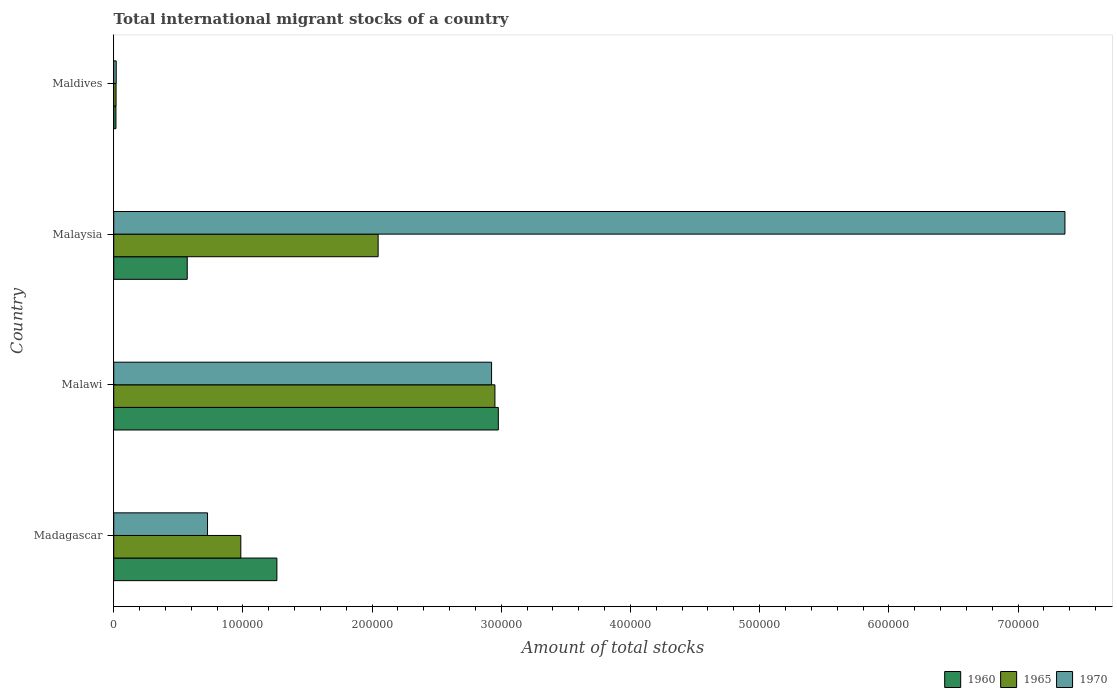How many different coloured bars are there?
Provide a succinct answer. 3. Are the number of bars on each tick of the Y-axis equal?
Keep it short and to the point. Yes. How many bars are there on the 4th tick from the top?
Your answer should be very brief. 3. What is the label of the 4th group of bars from the top?
Your response must be concise. Madagascar. In how many cases, is the number of bars for a given country not equal to the number of legend labels?
Keep it short and to the point. 0. What is the amount of total stocks in in 1960 in Malawi?
Make the answer very short. 2.98e+05. Across all countries, what is the maximum amount of total stocks in in 1960?
Your answer should be very brief. 2.98e+05. Across all countries, what is the minimum amount of total stocks in in 1970?
Provide a short and direct response. 1916. In which country was the amount of total stocks in in 1970 maximum?
Your response must be concise. Malaysia. In which country was the amount of total stocks in in 1970 minimum?
Provide a short and direct response. Maldives. What is the total amount of total stocks in in 1960 in the graph?
Give a very brief answer. 4.83e+05. What is the difference between the amount of total stocks in in 1965 in Malawi and that in Malaysia?
Make the answer very short. 9.04e+04. What is the difference between the amount of total stocks in in 1970 in Malaysia and the amount of total stocks in in 1965 in Maldives?
Keep it short and to the point. 7.35e+05. What is the average amount of total stocks in in 1970 per country?
Your answer should be compact. 2.76e+05. What is the difference between the amount of total stocks in in 1965 and amount of total stocks in in 1970 in Malawi?
Provide a succinct answer. 2608. In how many countries, is the amount of total stocks in in 1960 greater than 520000 ?
Ensure brevity in your answer.  0. What is the ratio of the amount of total stocks in in 1970 in Madagascar to that in Malaysia?
Ensure brevity in your answer.  0.1. What is the difference between the highest and the second highest amount of total stocks in in 1965?
Offer a terse response. 9.04e+04. What is the difference between the highest and the lowest amount of total stocks in in 1970?
Ensure brevity in your answer.  7.34e+05. What does the 2nd bar from the top in Malawi represents?
Make the answer very short. 1965. What does the 2nd bar from the bottom in Malawi represents?
Your response must be concise. 1965. Is it the case that in every country, the sum of the amount of total stocks in in 1970 and amount of total stocks in in 1965 is greater than the amount of total stocks in in 1960?
Make the answer very short. Yes. How many bars are there?
Provide a succinct answer. 12. Are all the bars in the graph horizontal?
Give a very brief answer. Yes. What is the difference between two consecutive major ticks on the X-axis?
Make the answer very short. 1.00e+05. Does the graph contain any zero values?
Your answer should be very brief. No. Where does the legend appear in the graph?
Keep it short and to the point. Bottom right. How are the legend labels stacked?
Give a very brief answer. Horizontal. What is the title of the graph?
Provide a succinct answer. Total international migrant stocks of a country. What is the label or title of the X-axis?
Keep it short and to the point. Amount of total stocks. What is the Amount of total stocks in 1960 in Madagascar?
Offer a very short reply. 1.26e+05. What is the Amount of total stocks of 1965 in Madagascar?
Make the answer very short. 9.84e+04. What is the Amount of total stocks of 1970 in Madagascar?
Provide a succinct answer. 7.26e+04. What is the Amount of total stocks of 1960 in Malawi?
Ensure brevity in your answer.  2.98e+05. What is the Amount of total stocks in 1965 in Malawi?
Give a very brief answer. 2.95e+05. What is the Amount of total stocks in 1970 in Malawi?
Your answer should be very brief. 2.92e+05. What is the Amount of total stocks in 1960 in Malaysia?
Offer a very short reply. 5.69e+04. What is the Amount of total stocks of 1965 in Malaysia?
Your response must be concise. 2.05e+05. What is the Amount of total stocks of 1970 in Malaysia?
Keep it short and to the point. 7.36e+05. What is the Amount of total stocks of 1960 in Maldives?
Offer a very short reply. 1703. What is the Amount of total stocks of 1965 in Maldives?
Provide a short and direct response. 1802. What is the Amount of total stocks in 1970 in Maldives?
Provide a succinct answer. 1916. Across all countries, what is the maximum Amount of total stocks in 1960?
Offer a terse response. 2.98e+05. Across all countries, what is the maximum Amount of total stocks of 1965?
Offer a terse response. 2.95e+05. Across all countries, what is the maximum Amount of total stocks in 1970?
Provide a succinct answer. 7.36e+05. Across all countries, what is the minimum Amount of total stocks in 1960?
Give a very brief answer. 1703. Across all countries, what is the minimum Amount of total stocks of 1965?
Ensure brevity in your answer.  1802. Across all countries, what is the minimum Amount of total stocks of 1970?
Keep it short and to the point. 1916. What is the total Amount of total stocks in 1960 in the graph?
Provide a succinct answer. 4.83e+05. What is the total Amount of total stocks of 1965 in the graph?
Your answer should be compact. 6.00e+05. What is the total Amount of total stocks of 1970 in the graph?
Your response must be concise. 1.10e+06. What is the difference between the Amount of total stocks of 1960 in Madagascar and that in Malawi?
Make the answer very short. -1.71e+05. What is the difference between the Amount of total stocks in 1965 in Madagascar and that in Malawi?
Your answer should be very brief. -1.97e+05. What is the difference between the Amount of total stocks of 1970 in Madagascar and that in Malawi?
Give a very brief answer. -2.20e+05. What is the difference between the Amount of total stocks in 1960 in Madagascar and that in Malaysia?
Make the answer very short. 6.94e+04. What is the difference between the Amount of total stocks of 1965 in Madagascar and that in Malaysia?
Keep it short and to the point. -1.06e+05. What is the difference between the Amount of total stocks in 1970 in Madagascar and that in Malaysia?
Keep it short and to the point. -6.64e+05. What is the difference between the Amount of total stocks in 1960 in Madagascar and that in Maldives?
Give a very brief answer. 1.25e+05. What is the difference between the Amount of total stocks of 1965 in Madagascar and that in Maldives?
Give a very brief answer. 9.66e+04. What is the difference between the Amount of total stocks in 1970 in Madagascar and that in Maldives?
Give a very brief answer. 7.07e+04. What is the difference between the Amount of total stocks of 1960 in Malawi and that in Malaysia?
Provide a succinct answer. 2.41e+05. What is the difference between the Amount of total stocks of 1965 in Malawi and that in Malaysia?
Give a very brief answer. 9.04e+04. What is the difference between the Amount of total stocks of 1970 in Malawi and that in Malaysia?
Keep it short and to the point. -4.44e+05. What is the difference between the Amount of total stocks in 1960 in Malawi and that in Maldives?
Your response must be concise. 2.96e+05. What is the difference between the Amount of total stocks of 1965 in Malawi and that in Maldives?
Offer a very short reply. 2.93e+05. What is the difference between the Amount of total stocks in 1970 in Malawi and that in Maldives?
Your response must be concise. 2.91e+05. What is the difference between the Amount of total stocks in 1960 in Malaysia and that in Maldives?
Make the answer very short. 5.52e+04. What is the difference between the Amount of total stocks of 1965 in Malaysia and that in Maldives?
Provide a short and direct response. 2.03e+05. What is the difference between the Amount of total stocks in 1970 in Malaysia and that in Maldives?
Provide a succinct answer. 7.34e+05. What is the difference between the Amount of total stocks in 1960 in Madagascar and the Amount of total stocks in 1965 in Malawi?
Your answer should be very brief. -1.69e+05. What is the difference between the Amount of total stocks in 1960 in Madagascar and the Amount of total stocks in 1970 in Malawi?
Your answer should be compact. -1.66e+05. What is the difference between the Amount of total stocks in 1965 in Madagascar and the Amount of total stocks in 1970 in Malawi?
Keep it short and to the point. -1.94e+05. What is the difference between the Amount of total stocks of 1960 in Madagascar and the Amount of total stocks of 1965 in Malaysia?
Your answer should be very brief. -7.84e+04. What is the difference between the Amount of total stocks in 1960 in Madagascar and the Amount of total stocks in 1970 in Malaysia?
Make the answer very short. -6.10e+05. What is the difference between the Amount of total stocks of 1965 in Madagascar and the Amount of total stocks of 1970 in Malaysia?
Keep it short and to the point. -6.38e+05. What is the difference between the Amount of total stocks in 1960 in Madagascar and the Amount of total stocks in 1965 in Maldives?
Offer a terse response. 1.24e+05. What is the difference between the Amount of total stocks of 1960 in Madagascar and the Amount of total stocks of 1970 in Maldives?
Offer a terse response. 1.24e+05. What is the difference between the Amount of total stocks in 1965 in Madagascar and the Amount of total stocks in 1970 in Maldives?
Your response must be concise. 9.64e+04. What is the difference between the Amount of total stocks in 1960 in Malawi and the Amount of total stocks in 1965 in Malaysia?
Offer a terse response. 9.30e+04. What is the difference between the Amount of total stocks in 1960 in Malawi and the Amount of total stocks in 1970 in Malaysia?
Give a very brief answer. -4.39e+05. What is the difference between the Amount of total stocks of 1965 in Malawi and the Amount of total stocks of 1970 in Malaysia?
Your answer should be very brief. -4.41e+05. What is the difference between the Amount of total stocks of 1960 in Malawi and the Amount of total stocks of 1965 in Maldives?
Give a very brief answer. 2.96e+05. What is the difference between the Amount of total stocks of 1960 in Malawi and the Amount of total stocks of 1970 in Maldives?
Offer a terse response. 2.96e+05. What is the difference between the Amount of total stocks in 1965 in Malawi and the Amount of total stocks in 1970 in Maldives?
Keep it short and to the point. 2.93e+05. What is the difference between the Amount of total stocks of 1960 in Malaysia and the Amount of total stocks of 1965 in Maldives?
Make the answer very short. 5.51e+04. What is the difference between the Amount of total stocks of 1960 in Malaysia and the Amount of total stocks of 1970 in Maldives?
Keep it short and to the point. 5.50e+04. What is the difference between the Amount of total stocks of 1965 in Malaysia and the Amount of total stocks of 1970 in Maldives?
Provide a short and direct response. 2.03e+05. What is the average Amount of total stocks in 1960 per country?
Keep it short and to the point. 1.21e+05. What is the average Amount of total stocks of 1965 per country?
Make the answer very short. 1.50e+05. What is the average Amount of total stocks of 1970 per country?
Give a very brief answer. 2.76e+05. What is the difference between the Amount of total stocks in 1960 and Amount of total stocks in 1965 in Madagascar?
Your response must be concise. 2.79e+04. What is the difference between the Amount of total stocks of 1960 and Amount of total stocks of 1970 in Madagascar?
Your response must be concise. 5.37e+04. What is the difference between the Amount of total stocks of 1965 and Amount of total stocks of 1970 in Madagascar?
Your answer should be compact. 2.58e+04. What is the difference between the Amount of total stocks of 1960 and Amount of total stocks of 1965 in Malawi?
Make the answer very short. 2632. What is the difference between the Amount of total stocks of 1960 and Amount of total stocks of 1970 in Malawi?
Keep it short and to the point. 5240. What is the difference between the Amount of total stocks of 1965 and Amount of total stocks of 1970 in Malawi?
Make the answer very short. 2608. What is the difference between the Amount of total stocks in 1960 and Amount of total stocks in 1965 in Malaysia?
Your response must be concise. -1.48e+05. What is the difference between the Amount of total stocks of 1960 and Amount of total stocks of 1970 in Malaysia?
Your answer should be compact. -6.79e+05. What is the difference between the Amount of total stocks of 1965 and Amount of total stocks of 1970 in Malaysia?
Your response must be concise. -5.32e+05. What is the difference between the Amount of total stocks of 1960 and Amount of total stocks of 1965 in Maldives?
Give a very brief answer. -99. What is the difference between the Amount of total stocks of 1960 and Amount of total stocks of 1970 in Maldives?
Keep it short and to the point. -213. What is the difference between the Amount of total stocks in 1965 and Amount of total stocks in 1970 in Maldives?
Offer a terse response. -114. What is the ratio of the Amount of total stocks in 1960 in Madagascar to that in Malawi?
Provide a succinct answer. 0.42. What is the ratio of the Amount of total stocks in 1970 in Madagascar to that in Malawi?
Provide a succinct answer. 0.25. What is the ratio of the Amount of total stocks of 1960 in Madagascar to that in Malaysia?
Provide a short and direct response. 2.22. What is the ratio of the Amount of total stocks of 1965 in Madagascar to that in Malaysia?
Provide a succinct answer. 0.48. What is the ratio of the Amount of total stocks of 1970 in Madagascar to that in Malaysia?
Keep it short and to the point. 0.1. What is the ratio of the Amount of total stocks of 1960 in Madagascar to that in Maldives?
Offer a terse response. 74.16. What is the ratio of the Amount of total stocks of 1965 in Madagascar to that in Maldives?
Offer a very short reply. 54.58. What is the ratio of the Amount of total stocks of 1970 in Madagascar to that in Maldives?
Ensure brevity in your answer.  37.89. What is the ratio of the Amount of total stocks of 1960 in Malawi to that in Malaysia?
Your answer should be compact. 5.23. What is the ratio of the Amount of total stocks of 1965 in Malawi to that in Malaysia?
Provide a succinct answer. 1.44. What is the ratio of the Amount of total stocks of 1970 in Malawi to that in Malaysia?
Provide a succinct answer. 0.4. What is the ratio of the Amount of total stocks of 1960 in Malawi to that in Maldives?
Provide a succinct answer. 174.81. What is the ratio of the Amount of total stocks in 1965 in Malawi to that in Maldives?
Offer a very short reply. 163.75. What is the ratio of the Amount of total stocks in 1970 in Malawi to that in Maldives?
Your answer should be very brief. 152.65. What is the ratio of the Amount of total stocks in 1960 in Malaysia to that in Maldives?
Provide a short and direct response. 33.41. What is the ratio of the Amount of total stocks in 1965 in Malaysia to that in Maldives?
Ensure brevity in your answer.  113.58. What is the ratio of the Amount of total stocks of 1970 in Malaysia to that in Maldives?
Your answer should be very brief. 384.3. What is the difference between the highest and the second highest Amount of total stocks in 1960?
Ensure brevity in your answer.  1.71e+05. What is the difference between the highest and the second highest Amount of total stocks in 1965?
Your answer should be very brief. 9.04e+04. What is the difference between the highest and the second highest Amount of total stocks in 1970?
Provide a succinct answer. 4.44e+05. What is the difference between the highest and the lowest Amount of total stocks in 1960?
Your answer should be very brief. 2.96e+05. What is the difference between the highest and the lowest Amount of total stocks of 1965?
Make the answer very short. 2.93e+05. What is the difference between the highest and the lowest Amount of total stocks in 1970?
Offer a very short reply. 7.34e+05. 